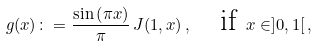Convert formula to latex. <formula><loc_0><loc_0><loc_500><loc_500>g ( x ) \colon = \frac { \sin \left ( \pi x \right ) } { \pi } \, J ( 1 , x ) \, , \quad \text {if } x \in ] 0 , 1 [ \, ,</formula> 